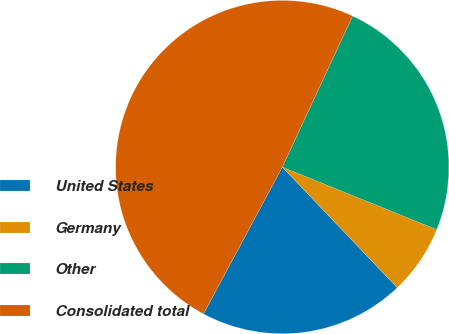<chart> <loc_0><loc_0><loc_500><loc_500><pie_chart><fcel>United States<fcel>Germany<fcel>Other<fcel>Consolidated total<nl><fcel>19.96%<fcel>6.76%<fcel>24.19%<fcel>49.09%<nl></chart> 